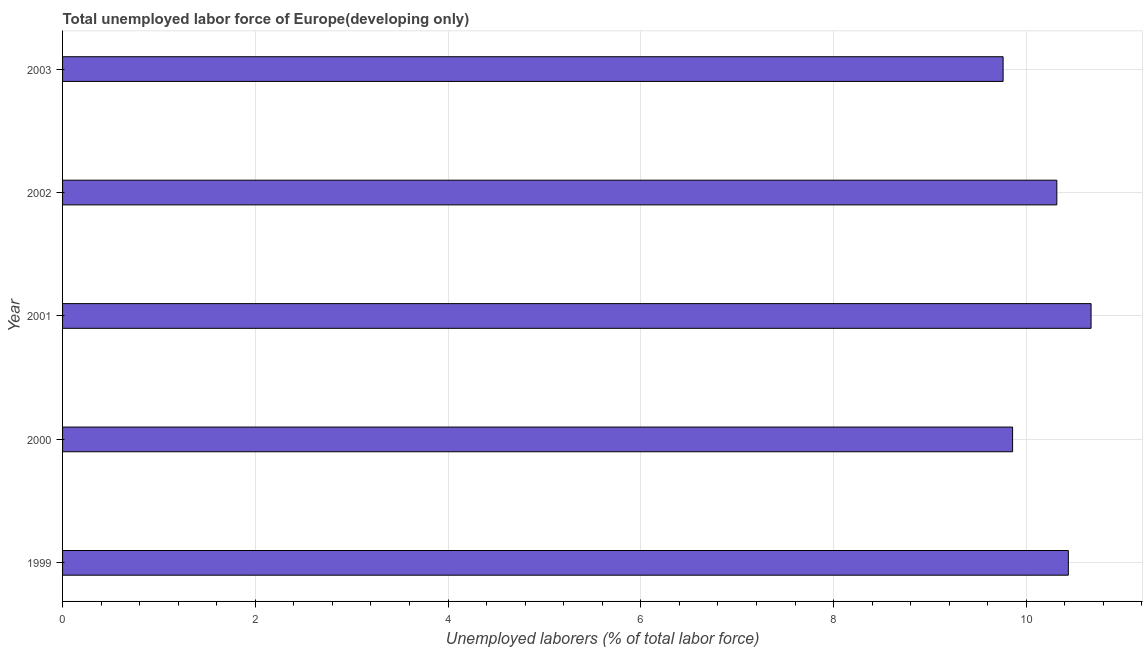Does the graph contain any zero values?
Provide a short and direct response. No. Does the graph contain grids?
Your answer should be compact. Yes. What is the title of the graph?
Keep it short and to the point. Total unemployed labor force of Europe(developing only). What is the label or title of the X-axis?
Provide a short and direct response. Unemployed laborers (% of total labor force). What is the label or title of the Y-axis?
Give a very brief answer. Year. What is the total unemployed labour force in 2000?
Make the answer very short. 9.86. Across all years, what is the maximum total unemployed labour force?
Ensure brevity in your answer.  10.67. Across all years, what is the minimum total unemployed labour force?
Make the answer very short. 9.76. In which year was the total unemployed labour force maximum?
Ensure brevity in your answer.  2001. In which year was the total unemployed labour force minimum?
Provide a short and direct response. 2003. What is the sum of the total unemployed labour force?
Your answer should be compact. 51.04. What is the difference between the total unemployed labour force in 1999 and 2002?
Ensure brevity in your answer.  0.12. What is the average total unemployed labour force per year?
Give a very brief answer. 10.21. What is the median total unemployed labour force?
Your answer should be very brief. 10.32. In how many years, is the total unemployed labour force greater than 1.6 %?
Your answer should be very brief. 5. Do a majority of the years between 1999 and 2001 (inclusive) have total unemployed labour force greater than 10.8 %?
Your answer should be compact. No. What is the ratio of the total unemployed labour force in 1999 to that in 2002?
Your answer should be compact. 1.01. Is the total unemployed labour force in 1999 less than that in 2002?
Your answer should be compact. No. Is the difference between the total unemployed labour force in 2002 and 2003 greater than the difference between any two years?
Provide a succinct answer. No. What is the difference between the highest and the second highest total unemployed labour force?
Give a very brief answer. 0.24. What is the difference between the highest and the lowest total unemployed labour force?
Provide a succinct answer. 0.91. How many bars are there?
Keep it short and to the point. 5. How many years are there in the graph?
Offer a terse response. 5. What is the difference between two consecutive major ticks on the X-axis?
Your response must be concise. 2. What is the Unemployed laborers (% of total labor force) in 1999?
Give a very brief answer. 10.44. What is the Unemployed laborers (% of total labor force) of 2000?
Provide a succinct answer. 9.86. What is the Unemployed laborers (% of total labor force) of 2001?
Your answer should be compact. 10.67. What is the Unemployed laborers (% of total labor force) of 2002?
Give a very brief answer. 10.32. What is the Unemployed laborers (% of total labor force) in 2003?
Your response must be concise. 9.76. What is the difference between the Unemployed laborers (% of total labor force) in 1999 and 2000?
Your response must be concise. 0.58. What is the difference between the Unemployed laborers (% of total labor force) in 1999 and 2001?
Keep it short and to the point. -0.24. What is the difference between the Unemployed laborers (% of total labor force) in 1999 and 2002?
Make the answer very short. 0.12. What is the difference between the Unemployed laborers (% of total labor force) in 1999 and 2003?
Offer a very short reply. 0.68. What is the difference between the Unemployed laborers (% of total labor force) in 2000 and 2001?
Offer a terse response. -0.81. What is the difference between the Unemployed laborers (% of total labor force) in 2000 and 2002?
Your response must be concise. -0.46. What is the difference between the Unemployed laborers (% of total labor force) in 2000 and 2003?
Make the answer very short. 0.1. What is the difference between the Unemployed laborers (% of total labor force) in 2001 and 2002?
Keep it short and to the point. 0.36. What is the difference between the Unemployed laborers (% of total labor force) in 2001 and 2003?
Offer a very short reply. 0.91. What is the difference between the Unemployed laborers (% of total labor force) in 2002 and 2003?
Offer a very short reply. 0.56. What is the ratio of the Unemployed laborers (% of total labor force) in 1999 to that in 2000?
Your response must be concise. 1.06. What is the ratio of the Unemployed laborers (% of total labor force) in 1999 to that in 2003?
Keep it short and to the point. 1.07. What is the ratio of the Unemployed laborers (% of total labor force) in 2000 to that in 2001?
Offer a very short reply. 0.92. What is the ratio of the Unemployed laborers (% of total labor force) in 2000 to that in 2002?
Offer a very short reply. 0.96. What is the ratio of the Unemployed laborers (% of total labor force) in 2000 to that in 2003?
Keep it short and to the point. 1.01. What is the ratio of the Unemployed laborers (% of total labor force) in 2001 to that in 2002?
Your answer should be very brief. 1.03. What is the ratio of the Unemployed laborers (% of total labor force) in 2001 to that in 2003?
Your answer should be compact. 1.09. What is the ratio of the Unemployed laborers (% of total labor force) in 2002 to that in 2003?
Offer a terse response. 1.06. 